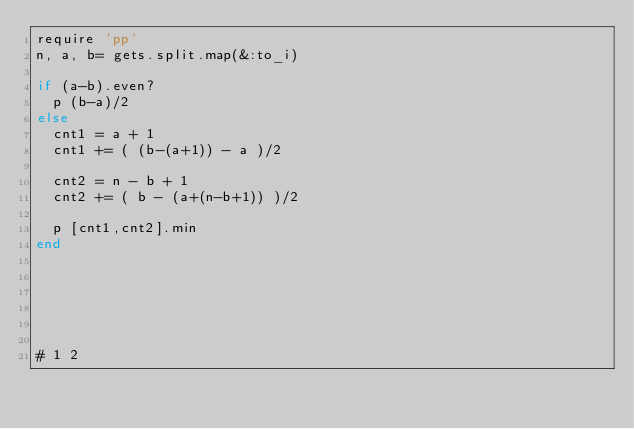<code> <loc_0><loc_0><loc_500><loc_500><_Ruby_>require 'pp'
n, a, b= gets.split.map(&:to_i)

if (a-b).even?
  p (b-a)/2
else
  cnt1 = a + 1
  cnt1 += ( (b-(a+1)) - a )/2
  
  cnt2 = n - b + 1
  cnt2 += ( b - (a+(n-b+1)) )/2

  p [cnt1,cnt2].min
end






# 1 2
</code> 